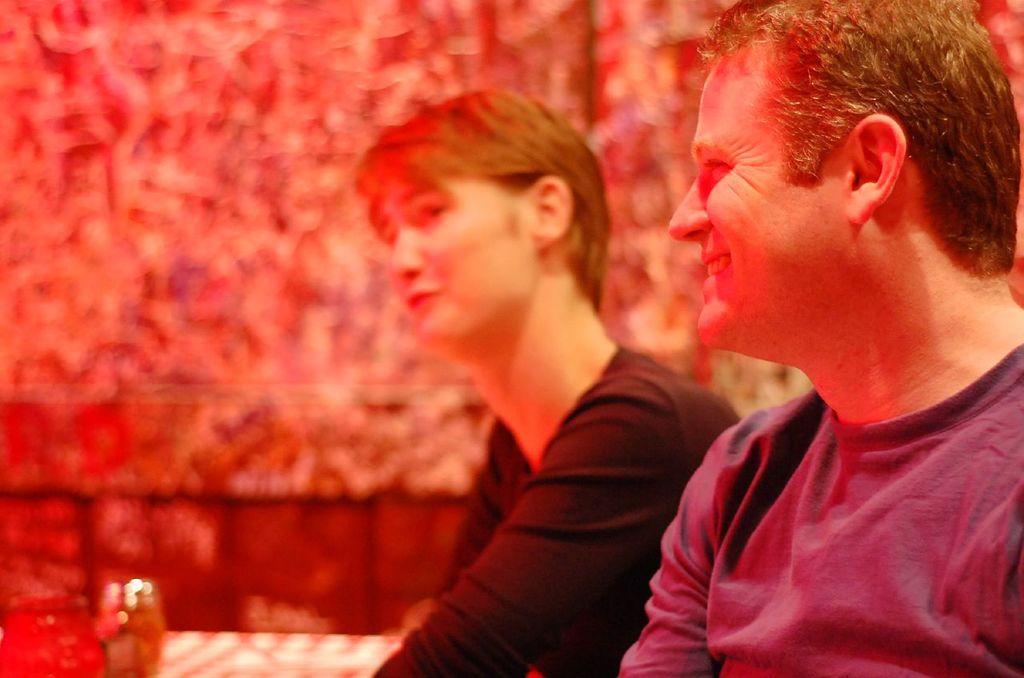Can you describe this image briefly? In this image, I can see two people sitting. The background looks red in color. This looks like an object. 